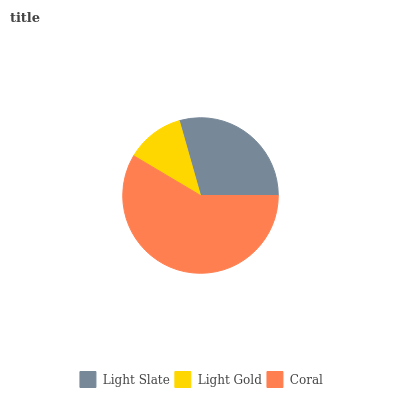Is Light Gold the minimum?
Answer yes or no. Yes. Is Coral the maximum?
Answer yes or no. Yes. Is Coral the minimum?
Answer yes or no. No. Is Light Gold the maximum?
Answer yes or no. No. Is Coral greater than Light Gold?
Answer yes or no. Yes. Is Light Gold less than Coral?
Answer yes or no. Yes. Is Light Gold greater than Coral?
Answer yes or no. No. Is Coral less than Light Gold?
Answer yes or no. No. Is Light Slate the high median?
Answer yes or no. Yes. Is Light Slate the low median?
Answer yes or no. Yes. Is Light Gold the high median?
Answer yes or no. No. Is Coral the low median?
Answer yes or no. No. 